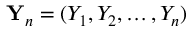<formula> <loc_0><loc_0><loc_500><loc_500>{ Y } _ { n } = ( Y _ { 1 } , Y _ { 2 } , \dots , Y _ { n } )</formula> 